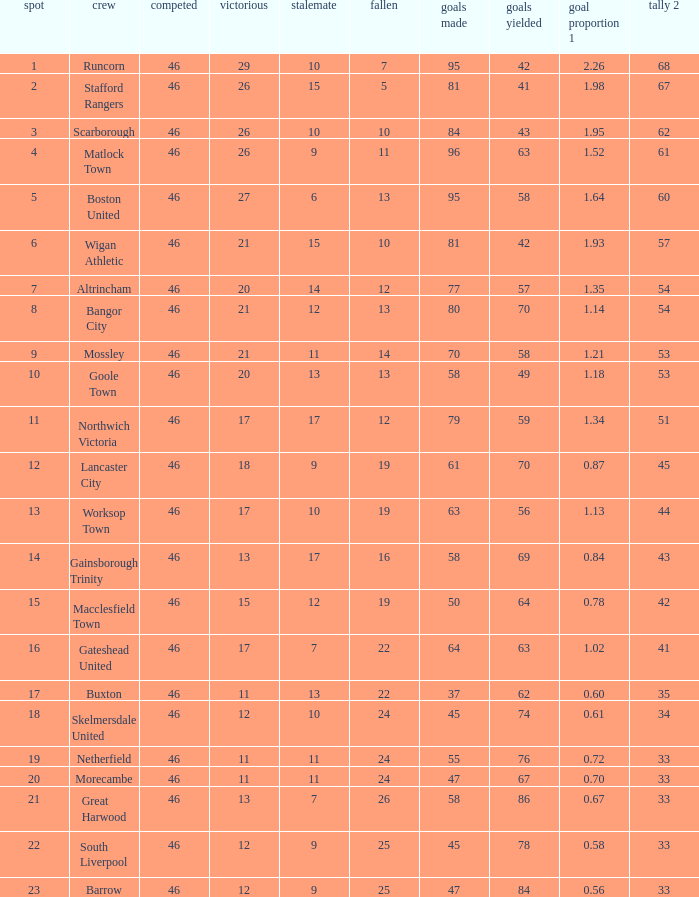How many times did the Lancaster City team play? 1.0. 